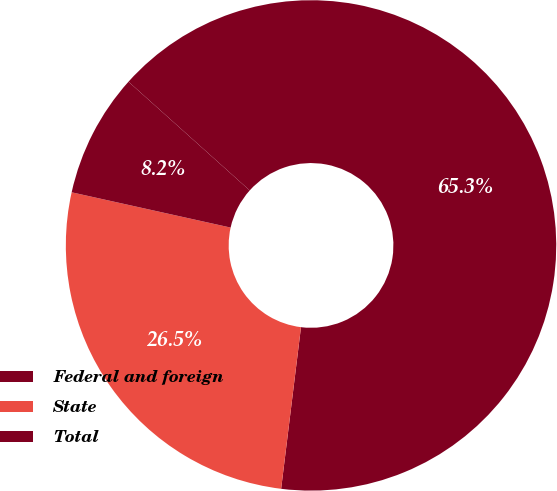<chart> <loc_0><loc_0><loc_500><loc_500><pie_chart><fcel>Federal and foreign<fcel>State<fcel>Total<nl><fcel>65.31%<fcel>26.53%<fcel>8.16%<nl></chart> 